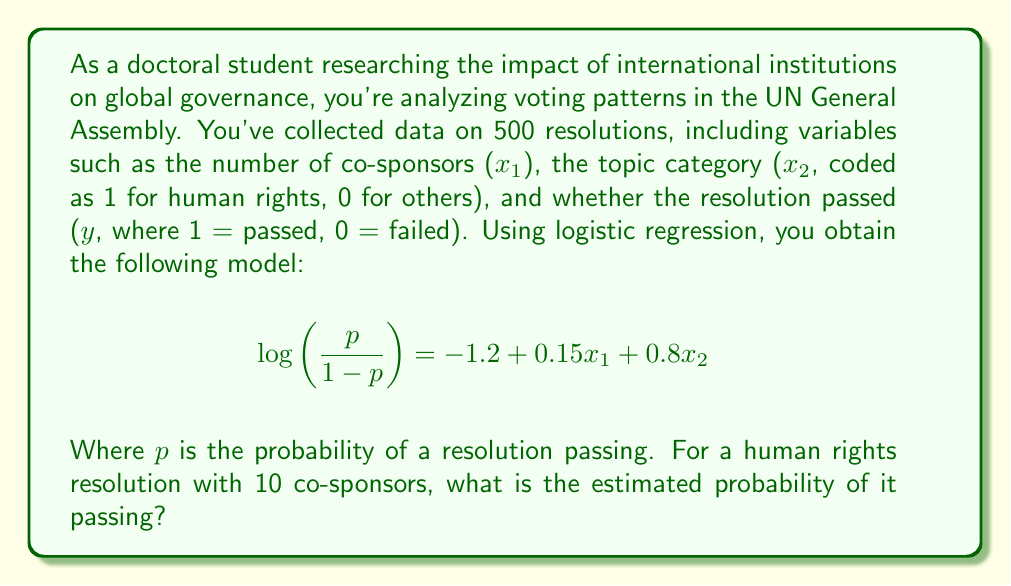What is the answer to this math problem? To solve this problem, we'll follow these steps:

1) First, we need to identify the values for our variables:
   $x_1 = 10$ (number of co-sponsors)
   $x_2 = 1$ (human rights topic)

2) We'll substitute these values into our logistic regression equation:

   $$\log\left(\frac{p}{1-p}\right) = -1.2 + 0.15(10) + 0.8(1)$$

3) Simplify:

   $$\log\left(\frac{p}{1-p}\right) = -1.2 + 1.5 + 0.8 = 1.1$$

4) This gives us the log-odds. To get the probability, we need to apply the inverse logit function:

   $$p = \frac{e^{1.1}}{1 + e^{1.1}}$$

5) Calculate:
   
   $$p = \frac{e^{1.1}}{1 + e^{1.1}} \approx \frac{3.0042}{4.0042} \approx 0.7502$$

Therefore, the estimated probability of this resolution passing is approximately 0.7502 or 75.02%.
Answer: 0.7502 or 75.02% 